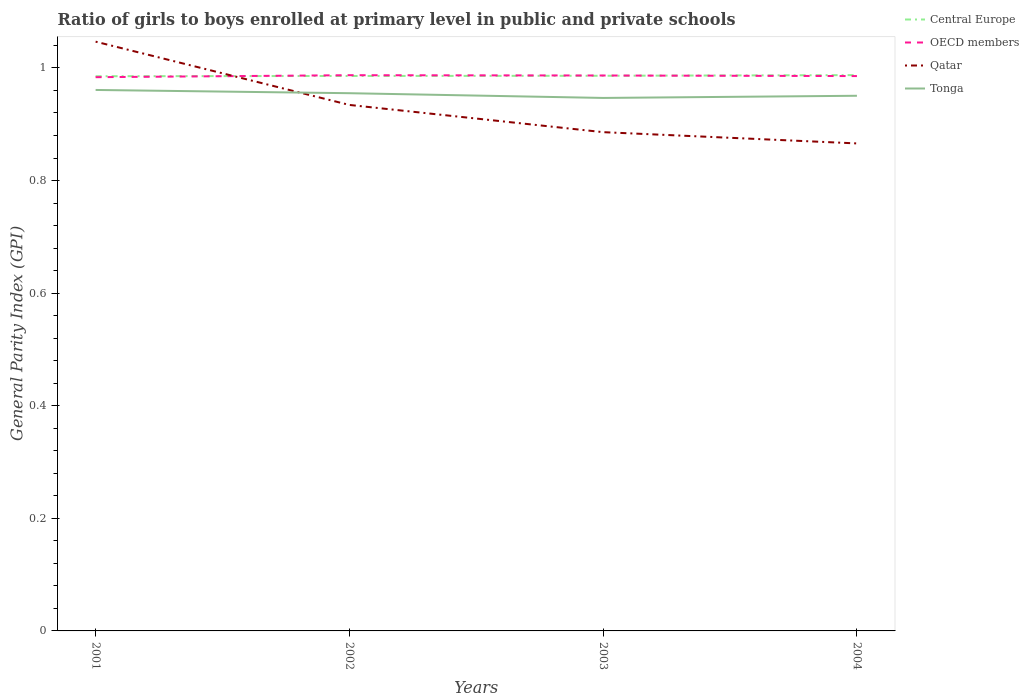Does the line corresponding to Central Europe intersect with the line corresponding to Tonga?
Provide a succinct answer. No. Across all years, what is the maximum general parity index in Tonga?
Keep it short and to the point. 0.95. In which year was the general parity index in OECD members maximum?
Offer a terse response. 2001. What is the total general parity index in Central Europe in the graph?
Your answer should be compact. -0. What is the difference between the highest and the second highest general parity index in Tonga?
Your answer should be compact. 0.01. What is the difference between the highest and the lowest general parity index in OECD members?
Make the answer very short. 2. How many lines are there?
Your response must be concise. 4. Does the graph contain grids?
Your answer should be compact. No. Where does the legend appear in the graph?
Provide a succinct answer. Top right. How many legend labels are there?
Make the answer very short. 4. How are the legend labels stacked?
Provide a succinct answer. Vertical. What is the title of the graph?
Offer a very short reply. Ratio of girls to boys enrolled at primary level in public and private schools. Does "Hong Kong" appear as one of the legend labels in the graph?
Provide a short and direct response. No. What is the label or title of the Y-axis?
Give a very brief answer. General Parity Index (GPI). What is the General Parity Index (GPI) of Central Europe in 2001?
Your response must be concise. 0.99. What is the General Parity Index (GPI) in OECD members in 2001?
Your response must be concise. 0.98. What is the General Parity Index (GPI) of Qatar in 2001?
Offer a terse response. 1.05. What is the General Parity Index (GPI) in Tonga in 2001?
Your response must be concise. 0.96. What is the General Parity Index (GPI) of Central Europe in 2002?
Your answer should be compact. 0.99. What is the General Parity Index (GPI) in OECD members in 2002?
Offer a terse response. 0.99. What is the General Parity Index (GPI) in Qatar in 2002?
Offer a very short reply. 0.93. What is the General Parity Index (GPI) in Tonga in 2002?
Give a very brief answer. 0.96. What is the General Parity Index (GPI) of Central Europe in 2003?
Make the answer very short. 0.99. What is the General Parity Index (GPI) in OECD members in 2003?
Keep it short and to the point. 0.99. What is the General Parity Index (GPI) of Qatar in 2003?
Ensure brevity in your answer.  0.89. What is the General Parity Index (GPI) of Tonga in 2003?
Offer a terse response. 0.95. What is the General Parity Index (GPI) of Central Europe in 2004?
Your response must be concise. 0.99. What is the General Parity Index (GPI) of OECD members in 2004?
Give a very brief answer. 0.99. What is the General Parity Index (GPI) of Qatar in 2004?
Give a very brief answer. 0.87. What is the General Parity Index (GPI) in Tonga in 2004?
Provide a short and direct response. 0.95. Across all years, what is the maximum General Parity Index (GPI) of Central Europe?
Offer a very short reply. 0.99. Across all years, what is the maximum General Parity Index (GPI) in OECD members?
Make the answer very short. 0.99. Across all years, what is the maximum General Parity Index (GPI) of Qatar?
Offer a very short reply. 1.05. Across all years, what is the maximum General Parity Index (GPI) of Tonga?
Offer a very short reply. 0.96. Across all years, what is the minimum General Parity Index (GPI) in Central Europe?
Your answer should be very brief. 0.99. Across all years, what is the minimum General Parity Index (GPI) of OECD members?
Your answer should be very brief. 0.98. Across all years, what is the minimum General Parity Index (GPI) in Qatar?
Make the answer very short. 0.87. Across all years, what is the minimum General Parity Index (GPI) in Tonga?
Your answer should be very brief. 0.95. What is the total General Parity Index (GPI) in Central Europe in the graph?
Provide a succinct answer. 3.94. What is the total General Parity Index (GPI) of OECD members in the graph?
Provide a short and direct response. 3.94. What is the total General Parity Index (GPI) of Qatar in the graph?
Ensure brevity in your answer.  3.73. What is the total General Parity Index (GPI) in Tonga in the graph?
Keep it short and to the point. 3.81. What is the difference between the General Parity Index (GPI) in Central Europe in 2001 and that in 2002?
Offer a very short reply. -0. What is the difference between the General Parity Index (GPI) in OECD members in 2001 and that in 2002?
Ensure brevity in your answer.  -0. What is the difference between the General Parity Index (GPI) of Qatar in 2001 and that in 2002?
Offer a terse response. 0.11. What is the difference between the General Parity Index (GPI) in Tonga in 2001 and that in 2002?
Make the answer very short. 0.01. What is the difference between the General Parity Index (GPI) of Central Europe in 2001 and that in 2003?
Provide a short and direct response. -0. What is the difference between the General Parity Index (GPI) of OECD members in 2001 and that in 2003?
Keep it short and to the point. -0. What is the difference between the General Parity Index (GPI) in Qatar in 2001 and that in 2003?
Your answer should be compact. 0.16. What is the difference between the General Parity Index (GPI) in Tonga in 2001 and that in 2003?
Your answer should be very brief. 0.01. What is the difference between the General Parity Index (GPI) in Central Europe in 2001 and that in 2004?
Offer a terse response. -0. What is the difference between the General Parity Index (GPI) in OECD members in 2001 and that in 2004?
Offer a terse response. -0. What is the difference between the General Parity Index (GPI) of Qatar in 2001 and that in 2004?
Offer a very short reply. 0.18. What is the difference between the General Parity Index (GPI) in Tonga in 2001 and that in 2004?
Provide a short and direct response. 0.01. What is the difference between the General Parity Index (GPI) of Central Europe in 2002 and that in 2003?
Offer a terse response. -0. What is the difference between the General Parity Index (GPI) in OECD members in 2002 and that in 2003?
Ensure brevity in your answer.  0. What is the difference between the General Parity Index (GPI) of Qatar in 2002 and that in 2003?
Keep it short and to the point. 0.05. What is the difference between the General Parity Index (GPI) of Tonga in 2002 and that in 2003?
Your response must be concise. 0.01. What is the difference between the General Parity Index (GPI) in Central Europe in 2002 and that in 2004?
Make the answer very short. -0. What is the difference between the General Parity Index (GPI) in OECD members in 2002 and that in 2004?
Provide a succinct answer. 0. What is the difference between the General Parity Index (GPI) of Qatar in 2002 and that in 2004?
Give a very brief answer. 0.07. What is the difference between the General Parity Index (GPI) in Tonga in 2002 and that in 2004?
Your answer should be compact. 0. What is the difference between the General Parity Index (GPI) of Central Europe in 2003 and that in 2004?
Give a very brief answer. -0. What is the difference between the General Parity Index (GPI) of Qatar in 2003 and that in 2004?
Your response must be concise. 0.02. What is the difference between the General Parity Index (GPI) of Tonga in 2003 and that in 2004?
Provide a short and direct response. -0. What is the difference between the General Parity Index (GPI) of Central Europe in 2001 and the General Parity Index (GPI) of OECD members in 2002?
Your response must be concise. -0. What is the difference between the General Parity Index (GPI) of Central Europe in 2001 and the General Parity Index (GPI) of Qatar in 2002?
Offer a terse response. 0.05. What is the difference between the General Parity Index (GPI) in Central Europe in 2001 and the General Parity Index (GPI) in Tonga in 2002?
Offer a very short reply. 0.03. What is the difference between the General Parity Index (GPI) in OECD members in 2001 and the General Parity Index (GPI) in Qatar in 2002?
Ensure brevity in your answer.  0.05. What is the difference between the General Parity Index (GPI) in OECD members in 2001 and the General Parity Index (GPI) in Tonga in 2002?
Make the answer very short. 0.03. What is the difference between the General Parity Index (GPI) in Qatar in 2001 and the General Parity Index (GPI) in Tonga in 2002?
Make the answer very short. 0.09. What is the difference between the General Parity Index (GPI) in Central Europe in 2001 and the General Parity Index (GPI) in OECD members in 2003?
Offer a very short reply. -0. What is the difference between the General Parity Index (GPI) of Central Europe in 2001 and the General Parity Index (GPI) of Qatar in 2003?
Keep it short and to the point. 0.1. What is the difference between the General Parity Index (GPI) of Central Europe in 2001 and the General Parity Index (GPI) of Tonga in 2003?
Keep it short and to the point. 0.04. What is the difference between the General Parity Index (GPI) of OECD members in 2001 and the General Parity Index (GPI) of Qatar in 2003?
Offer a very short reply. 0.1. What is the difference between the General Parity Index (GPI) in OECD members in 2001 and the General Parity Index (GPI) in Tonga in 2003?
Offer a very short reply. 0.04. What is the difference between the General Parity Index (GPI) of Qatar in 2001 and the General Parity Index (GPI) of Tonga in 2003?
Offer a terse response. 0.1. What is the difference between the General Parity Index (GPI) of Central Europe in 2001 and the General Parity Index (GPI) of OECD members in 2004?
Ensure brevity in your answer.  -0. What is the difference between the General Parity Index (GPI) in Central Europe in 2001 and the General Parity Index (GPI) in Qatar in 2004?
Your answer should be compact. 0.12. What is the difference between the General Parity Index (GPI) in Central Europe in 2001 and the General Parity Index (GPI) in Tonga in 2004?
Your response must be concise. 0.03. What is the difference between the General Parity Index (GPI) in OECD members in 2001 and the General Parity Index (GPI) in Qatar in 2004?
Make the answer very short. 0.12. What is the difference between the General Parity Index (GPI) of OECD members in 2001 and the General Parity Index (GPI) of Tonga in 2004?
Provide a short and direct response. 0.03. What is the difference between the General Parity Index (GPI) of Qatar in 2001 and the General Parity Index (GPI) of Tonga in 2004?
Keep it short and to the point. 0.1. What is the difference between the General Parity Index (GPI) in Central Europe in 2002 and the General Parity Index (GPI) in OECD members in 2003?
Your response must be concise. -0. What is the difference between the General Parity Index (GPI) of Central Europe in 2002 and the General Parity Index (GPI) of Qatar in 2003?
Provide a short and direct response. 0.1. What is the difference between the General Parity Index (GPI) in Central Europe in 2002 and the General Parity Index (GPI) in Tonga in 2003?
Your answer should be very brief. 0.04. What is the difference between the General Parity Index (GPI) in OECD members in 2002 and the General Parity Index (GPI) in Qatar in 2003?
Offer a very short reply. 0.1. What is the difference between the General Parity Index (GPI) in OECD members in 2002 and the General Parity Index (GPI) in Tonga in 2003?
Make the answer very short. 0.04. What is the difference between the General Parity Index (GPI) of Qatar in 2002 and the General Parity Index (GPI) of Tonga in 2003?
Provide a short and direct response. -0.01. What is the difference between the General Parity Index (GPI) in Central Europe in 2002 and the General Parity Index (GPI) in Qatar in 2004?
Keep it short and to the point. 0.12. What is the difference between the General Parity Index (GPI) in Central Europe in 2002 and the General Parity Index (GPI) in Tonga in 2004?
Your answer should be compact. 0.04. What is the difference between the General Parity Index (GPI) in OECD members in 2002 and the General Parity Index (GPI) in Qatar in 2004?
Ensure brevity in your answer.  0.12. What is the difference between the General Parity Index (GPI) of OECD members in 2002 and the General Parity Index (GPI) of Tonga in 2004?
Give a very brief answer. 0.04. What is the difference between the General Parity Index (GPI) of Qatar in 2002 and the General Parity Index (GPI) of Tonga in 2004?
Offer a very short reply. -0.02. What is the difference between the General Parity Index (GPI) of Central Europe in 2003 and the General Parity Index (GPI) of OECD members in 2004?
Keep it short and to the point. 0. What is the difference between the General Parity Index (GPI) of Central Europe in 2003 and the General Parity Index (GPI) of Qatar in 2004?
Make the answer very short. 0.12. What is the difference between the General Parity Index (GPI) of Central Europe in 2003 and the General Parity Index (GPI) of Tonga in 2004?
Keep it short and to the point. 0.04. What is the difference between the General Parity Index (GPI) of OECD members in 2003 and the General Parity Index (GPI) of Qatar in 2004?
Ensure brevity in your answer.  0.12. What is the difference between the General Parity Index (GPI) of OECD members in 2003 and the General Parity Index (GPI) of Tonga in 2004?
Offer a terse response. 0.04. What is the difference between the General Parity Index (GPI) in Qatar in 2003 and the General Parity Index (GPI) in Tonga in 2004?
Your response must be concise. -0.06. What is the average General Parity Index (GPI) of Central Europe per year?
Offer a very short reply. 0.99. What is the average General Parity Index (GPI) of OECD members per year?
Provide a short and direct response. 0.99. What is the average General Parity Index (GPI) of Qatar per year?
Your response must be concise. 0.93. What is the average General Parity Index (GPI) in Tonga per year?
Your answer should be very brief. 0.95. In the year 2001, what is the difference between the General Parity Index (GPI) in Central Europe and General Parity Index (GPI) in OECD members?
Your answer should be compact. 0. In the year 2001, what is the difference between the General Parity Index (GPI) of Central Europe and General Parity Index (GPI) of Qatar?
Your response must be concise. -0.06. In the year 2001, what is the difference between the General Parity Index (GPI) of Central Europe and General Parity Index (GPI) of Tonga?
Offer a terse response. 0.02. In the year 2001, what is the difference between the General Parity Index (GPI) of OECD members and General Parity Index (GPI) of Qatar?
Provide a succinct answer. -0.06. In the year 2001, what is the difference between the General Parity Index (GPI) in OECD members and General Parity Index (GPI) in Tonga?
Make the answer very short. 0.02. In the year 2001, what is the difference between the General Parity Index (GPI) in Qatar and General Parity Index (GPI) in Tonga?
Provide a succinct answer. 0.09. In the year 2002, what is the difference between the General Parity Index (GPI) in Central Europe and General Parity Index (GPI) in OECD members?
Your answer should be very brief. -0. In the year 2002, what is the difference between the General Parity Index (GPI) of Central Europe and General Parity Index (GPI) of Qatar?
Offer a terse response. 0.05. In the year 2002, what is the difference between the General Parity Index (GPI) in Central Europe and General Parity Index (GPI) in Tonga?
Keep it short and to the point. 0.03. In the year 2002, what is the difference between the General Parity Index (GPI) in OECD members and General Parity Index (GPI) in Qatar?
Provide a succinct answer. 0.05. In the year 2002, what is the difference between the General Parity Index (GPI) in OECD members and General Parity Index (GPI) in Tonga?
Keep it short and to the point. 0.03. In the year 2002, what is the difference between the General Parity Index (GPI) of Qatar and General Parity Index (GPI) of Tonga?
Your response must be concise. -0.02. In the year 2003, what is the difference between the General Parity Index (GPI) in Central Europe and General Parity Index (GPI) in OECD members?
Make the answer very short. -0. In the year 2003, what is the difference between the General Parity Index (GPI) in Central Europe and General Parity Index (GPI) in Qatar?
Give a very brief answer. 0.1. In the year 2003, what is the difference between the General Parity Index (GPI) in Central Europe and General Parity Index (GPI) in Tonga?
Your response must be concise. 0.04. In the year 2003, what is the difference between the General Parity Index (GPI) of OECD members and General Parity Index (GPI) of Qatar?
Provide a succinct answer. 0.1. In the year 2003, what is the difference between the General Parity Index (GPI) in OECD members and General Parity Index (GPI) in Tonga?
Your response must be concise. 0.04. In the year 2003, what is the difference between the General Parity Index (GPI) in Qatar and General Parity Index (GPI) in Tonga?
Provide a short and direct response. -0.06. In the year 2004, what is the difference between the General Parity Index (GPI) of Central Europe and General Parity Index (GPI) of OECD members?
Keep it short and to the point. 0. In the year 2004, what is the difference between the General Parity Index (GPI) of Central Europe and General Parity Index (GPI) of Qatar?
Your answer should be very brief. 0.12. In the year 2004, what is the difference between the General Parity Index (GPI) in Central Europe and General Parity Index (GPI) in Tonga?
Your response must be concise. 0.04. In the year 2004, what is the difference between the General Parity Index (GPI) of OECD members and General Parity Index (GPI) of Qatar?
Make the answer very short. 0.12. In the year 2004, what is the difference between the General Parity Index (GPI) in OECD members and General Parity Index (GPI) in Tonga?
Your response must be concise. 0.04. In the year 2004, what is the difference between the General Parity Index (GPI) in Qatar and General Parity Index (GPI) in Tonga?
Make the answer very short. -0.08. What is the ratio of the General Parity Index (GPI) of OECD members in 2001 to that in 2002?
Give a very brief answer. 1. What is the ratio of the General Parity Index (GPI) of Qatar in 2001 to that in 2002?
Your answer should be very brief. 1.12. What is the ratio of the General Parity Index (GPI) of Tonga in 2001 to that in 2002?
Your response must be concise. 1.01. What is the ratio of the General Parity Index (GPI) of Central Europe in 2001 to that in 2003?
Offer a terse response. 1. What is the ratio of the General Parity Index (GPI) of Qatar in 2001 to that in 2003?
Provide a succinct answer. 1.18. What is the ratio of the General Parity Index (GPI) in Tonga in 2001 to that in 2003?
Make the answer very short. 1.01. What is the ratio of the General Parity Index (GPI) in Central Europe in 2001 to that in 2004?
Your answer should be very brief. 1. What is the ratio of the General Parity Index (GPI) in OECD members in 2001 to that in 2004?
Your response must be concise. 1. What is the ratio of the General Parity Index (GPI) in Qatar in 2001 to that in 2004?
Provide a short and direct response. 1.21. What is the ratio of the General Parity Index (GPI) in Tonga in 2001 to that in 2004?
Your response must be concise. 1.01. What is the ratio of the General Parity Index (GPI) of Central Europe in 2002 to that in 2003?
Make the answer very short. 1. What is the ratio of the General Parity Index (GPI) in Qatar in 2002 to that in 2003?
Offer a terse response. 1.05. What is the ratio of the General Parity Index (GPI) in Tonga in 2002 to that in 2003?
Ensure brevity in your answer.  1.01. What is the ratio of the General Parity Index (GPI) of OECD members in 2002 to that in 2004?
Give a very brief answer. 1. What is the ratio of the General Parity Index (GPI) in Qatar in 2002 to that in 2004?
Provide a short and direct response. 1.08. What is the ratio of the General Parity Index (GPI) in Tonga in 2002 to that in 2004?
Your response must be concise. 1. What is the ratio of the General Parity Index (GPI) in Central Europe in 2003 to that in 2004?
Provide a short and direct response. 1. What is the ratio of the General Parity Index (GPI) of Qatar in 2003 to that in 2004?
Provide a short and direct response. 1.02. What is the ratio of the General Parity Index (GPI) in Tonga in 2003 to that in 2004?
Your answer should be very brief. 1. What is the difference between the highest and the second highest General Parity Index (GPI) of Central Europe?
Offer a terse response. 0. What is the difference between the highest and the second highest General Parity Index (GPI) in Qatar?
Your answer should be very brief. 0.11. What is the difference between the highest and the second highest General Parity Index (GPI) of Tonga?
Your answer should be very brief. 0.01. What is the difference between the highest and the lowest General Parity Index (GPI) of Central Europe?
Give a very brief answer. 0. What is the difference between the highest and the lowest General Parity Index (GPI) of OECD members?
Make the answer very short. 0. What is the difference between the highest and the lowest General Parity Index (GPI) of Qatar?
Your answer should be very brief. 0.18. What is the difference between the highest and the lowest General Parity Index (GPI) in Tonga?
Your answer should be compact. 0.01. 